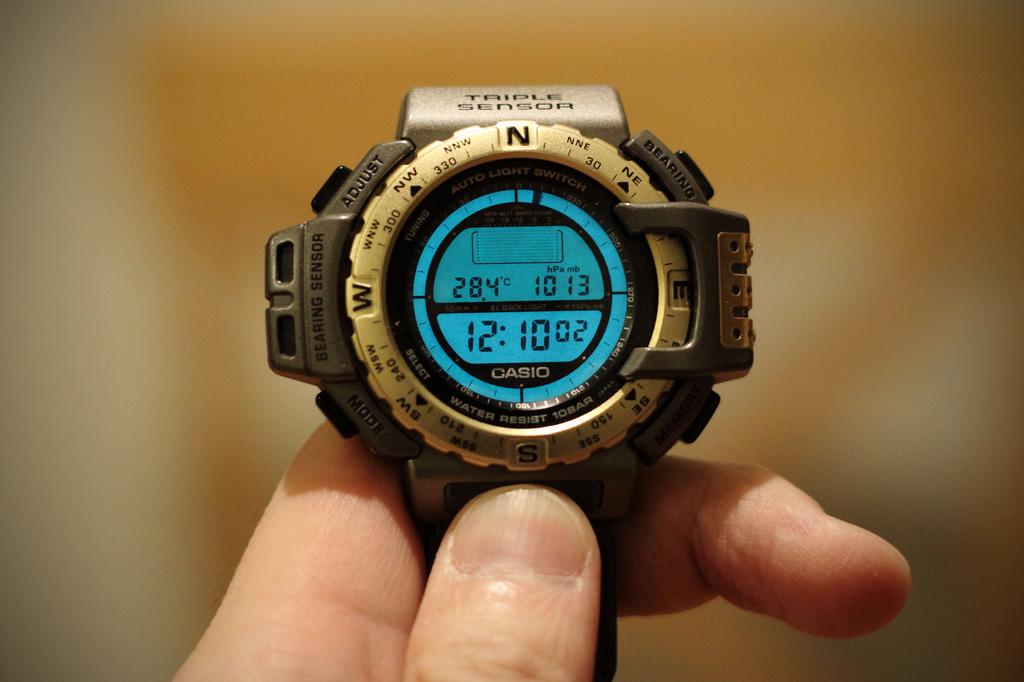Provide a one-sentence caption for the provided image. A indigo watch has the words AUTO LITGHT SWITCH printed on its face. 